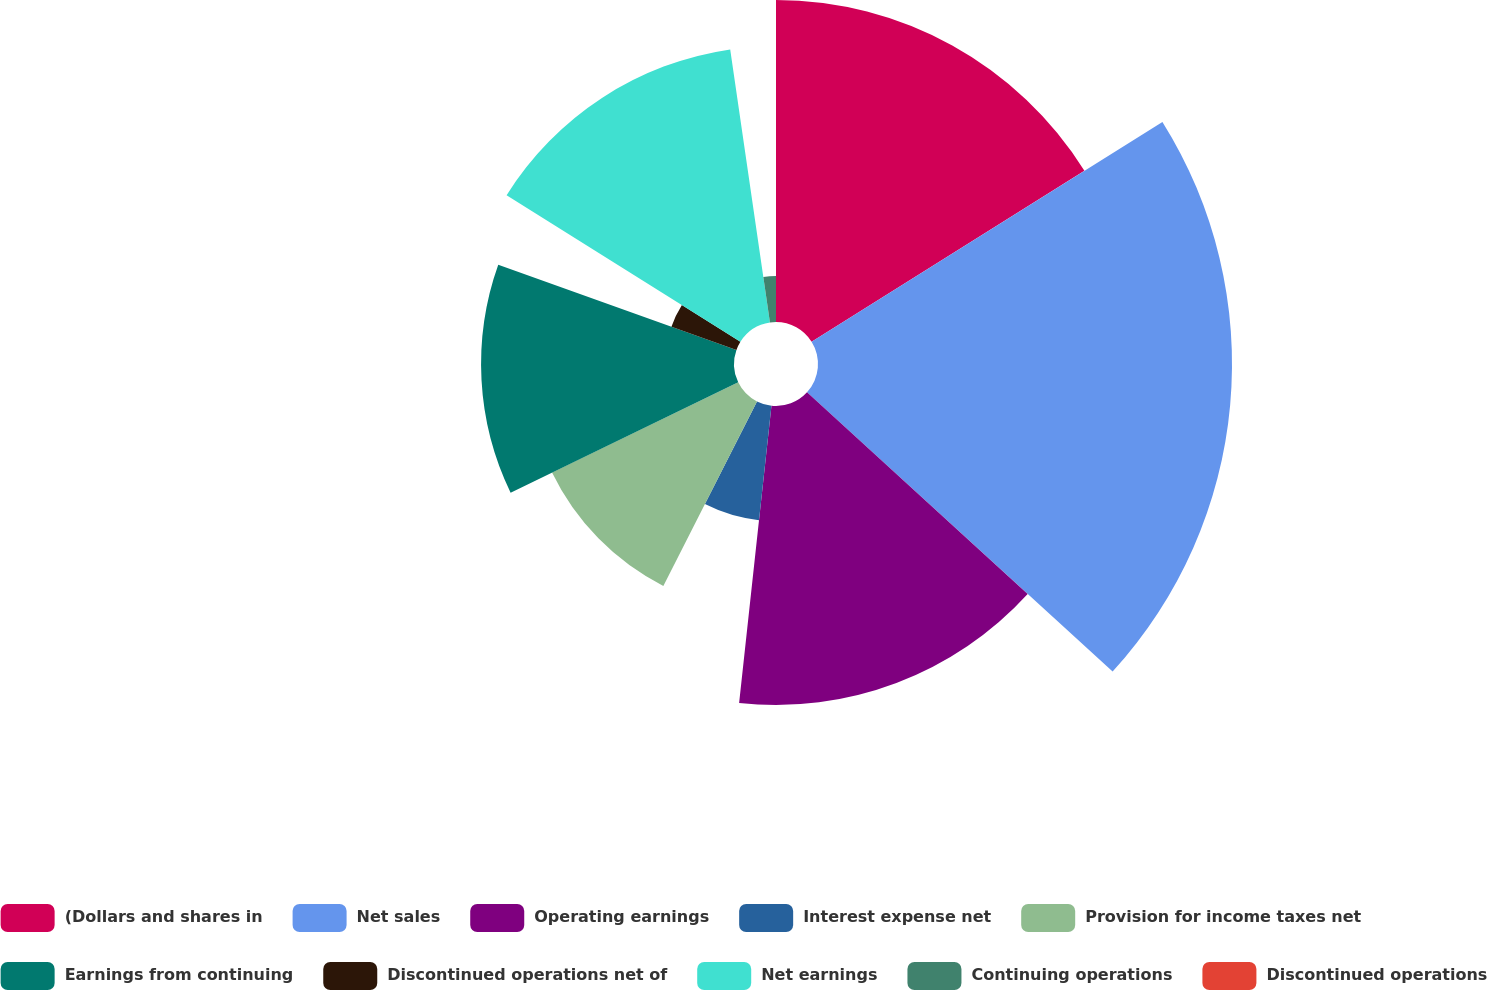Convert chart. <chart><loc_0><loc_0><loc_500><loc_500><pie_chart><fcel>(Dollars and shares in<fcel>Net sales<fcel>Operating earnings<fcel>Interest expense net<fcel>Provision for income taxes net<fcel>Earnings from continuing<fcel>Discontinued operations net of<fcel>Net earnings<fcel>Continuing operations<fcel>Discontinued operations<nl><fcel>16.09%<fcel>20.69%<fcel>14.94%<fcel>5.75%<fcel>10.34%<fcel>12.64%<fcel>3.45%<fcel>13.79%<fcel>2.3%<fcel>0.0%<nl></chart> 